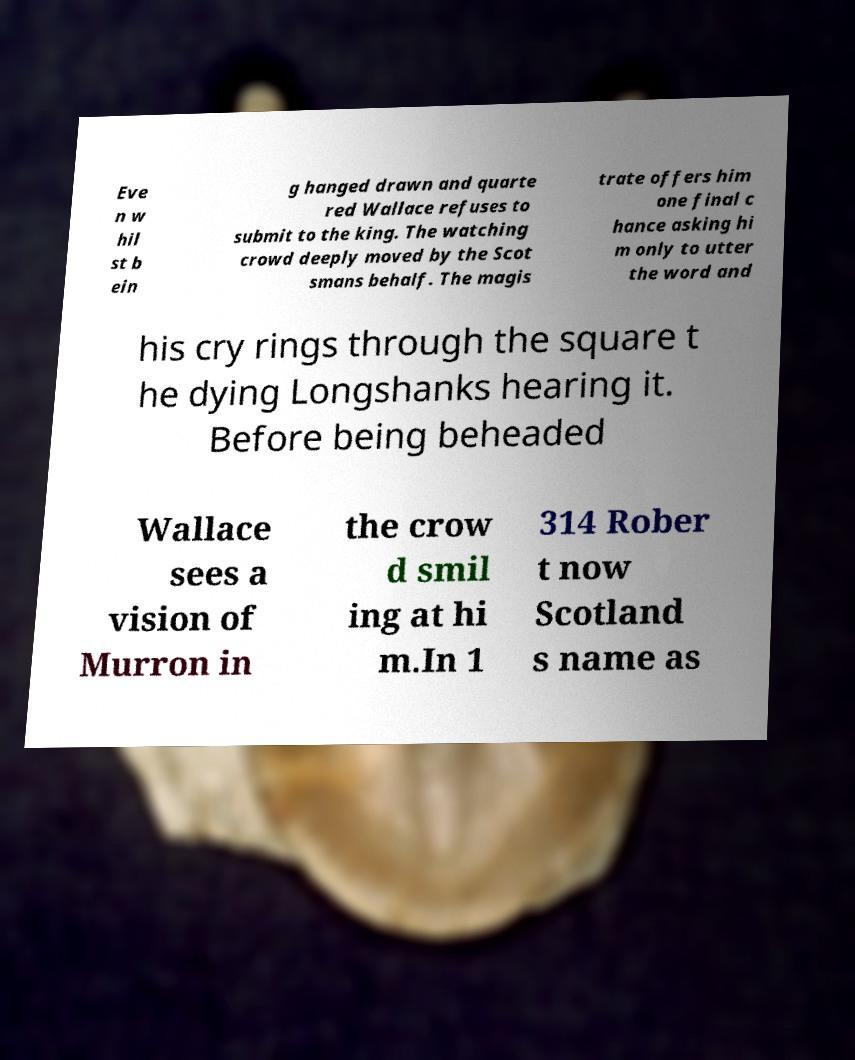Could you extract and type out the text from this image? Eve n w hil st b ein g hanged drawn and quarte red Wallace refuses to submit to the king. The watching crowd deeply moved by the Scot smans behalf. The magis trate offers him one final c hance asking hi m only to utter the word and his cry rings through the square t he dying Longshanks hearing it. Before being beheaded Wallace sees a vision of Murron in the crow d smil ing at hi m.In 1 314 Rober t now Scotland s name as 